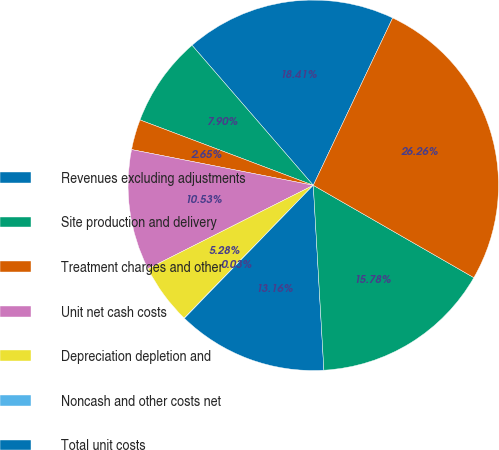Convert chart to OTSL. <chart><loc_0><loc_0><loc_500><loc_500><pie_chart><fcel>Revenues excluding adjustments<fcel>Site production and delivery<fcel>Treatment charges and other<fcel>Unit net cash costs<fcel>Depreciation depletion and<fcel>Noncash and other costs net<fcel>Total unit costs<fcel>Gross profit per pound^a<fcel>Molybdenum sales (millions of<nl><fcel>18.41%<fcel>7.9%<fcel>2.65%<fcel>10.53%<fcel>5.28%<fcel>0.03%<fcel>13.16%<fcel>15.78%<fcel>26.26%<nl></chart> 